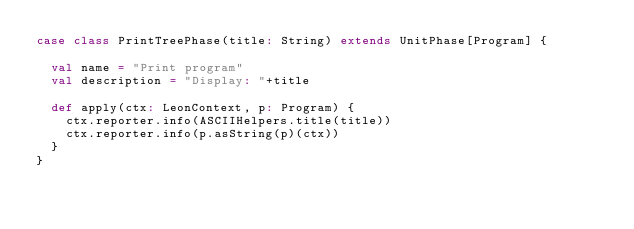<code> <loc_0><loc_0><loc_500><loc_500><_Scala_>case class PrintTreePhase(title: String) extends UnitPhase[Program] {

  val name = "Print program"
  val description = "Display: "+title

  def apply(ctx: LeonContext, p: Program) {
    ctx.reporter.info(ASCIIHelpers.title(title))
    ctx.reporter.info(p.asString(p)(ctx))
  }
}
</code> 